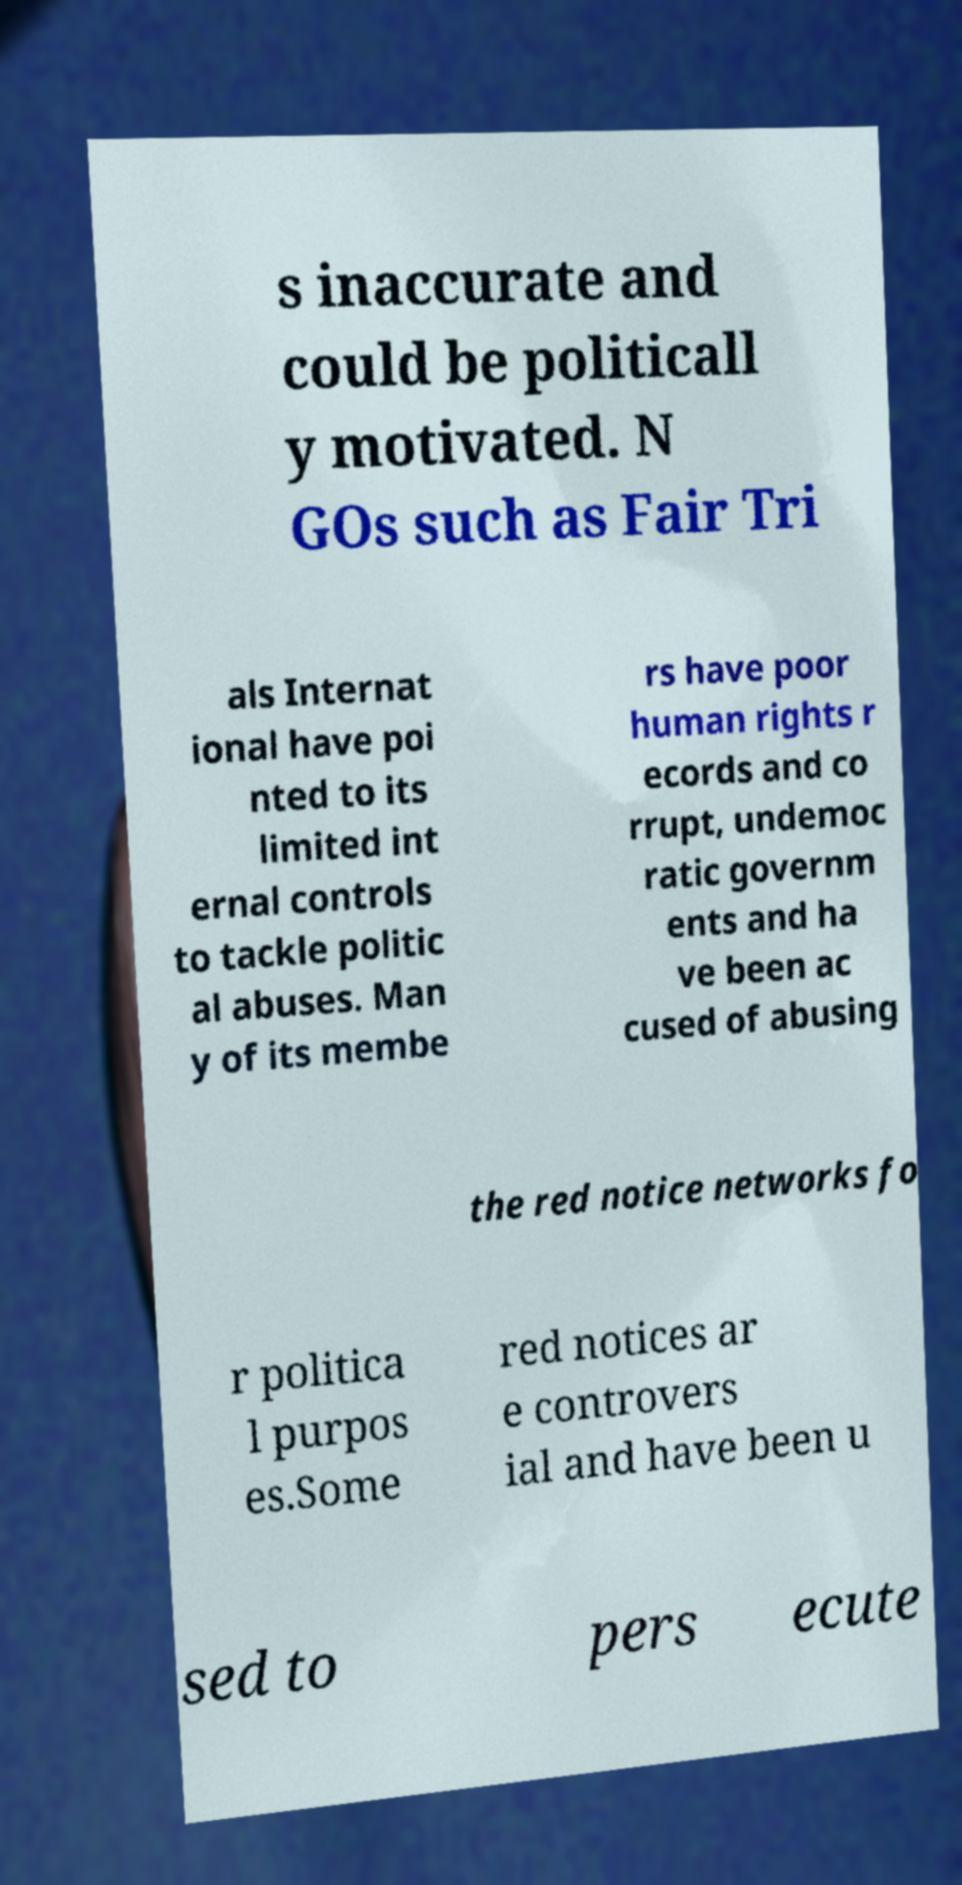Could you assist in decoding the text presented in this image and type it out clearly? s inaccurate and could be politicall y motivated. N GOs such as Fair Tri als Internat ional have poi nted to its limited int ernal controls to tackle politic al abuses. Man y of its membe rs have poor human rights r ecords and co rrupt, undemoc ratic governm ents and ha ve been ac cused of abusing the red notice networks fo r politica l purpos es.Some red notices ar e controvers ial and have been u sed to pers ecute 